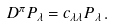<formula> <loc_0><loc_0><loc_500><loc_500>D ^ { \pi } P _ { \lambda } = c _ { \lambda \lambda } P _ { \lambda } \, .</formula> 